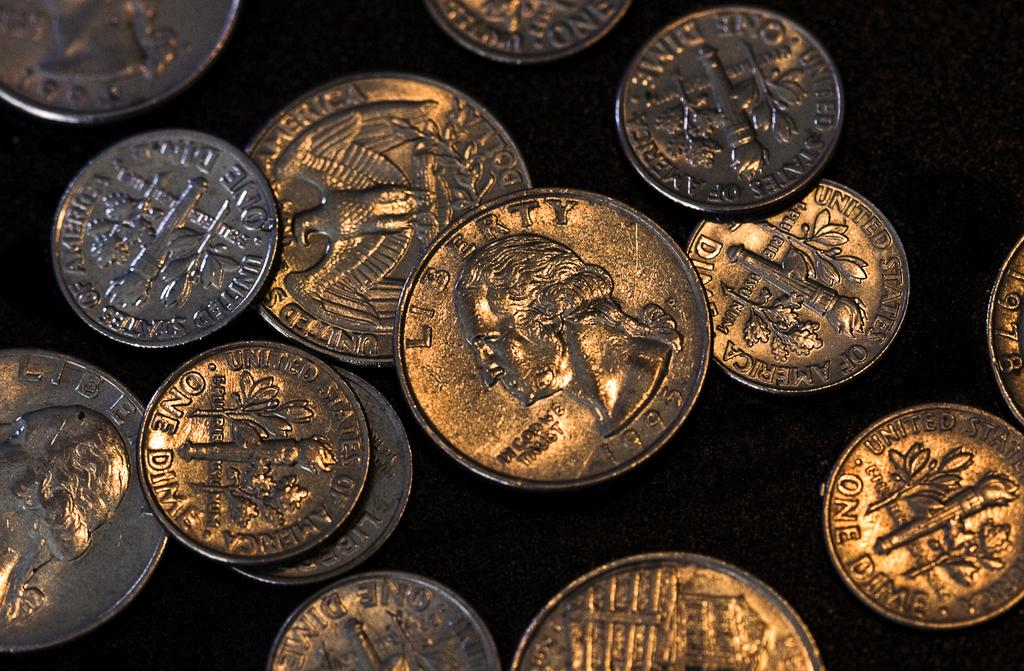<image>
Summarize the visual content of the image. A group of dimes and quarters with the word Liberty on the front of the quarters. 